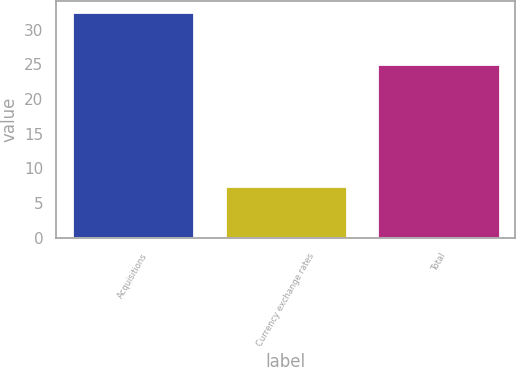Convert chart to OTSL. <chart><loc_0><loc_0><loc_500><loc_500><bar_chart><fcel>Acquisitions<fcel>Currency exchange rates<fcel>Total<nl><fcel>32.5<fcel>7.5<fcel>25<nl></chart> 